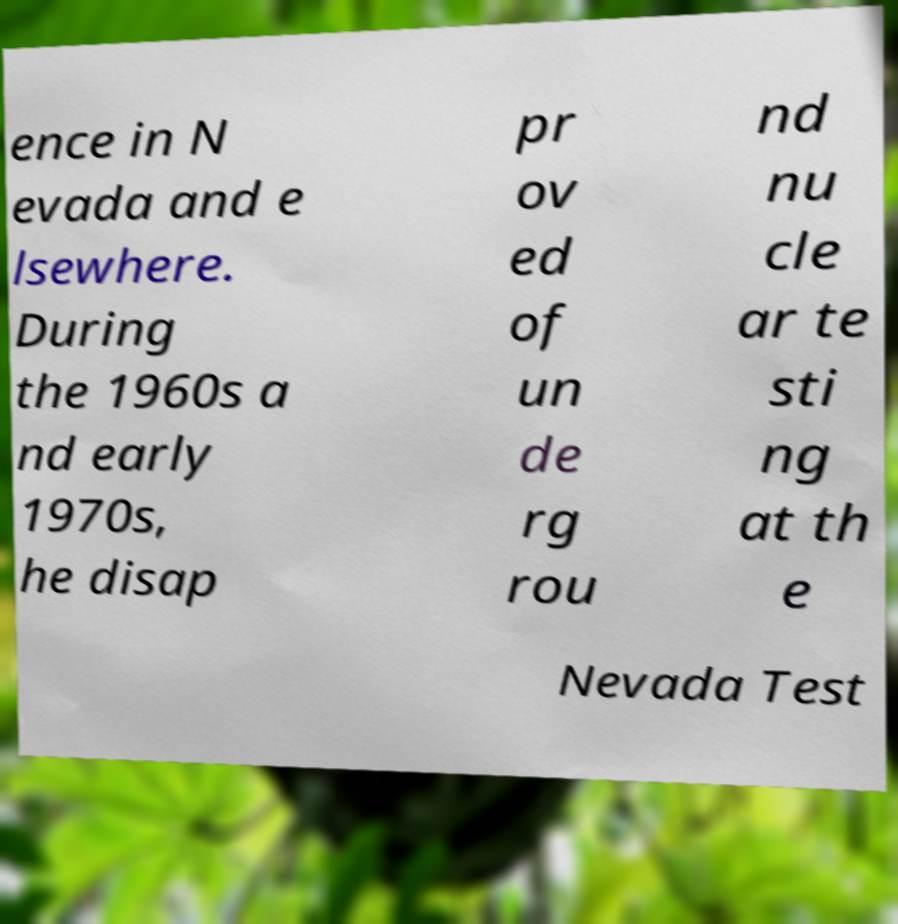Could you extract and type out the text from this image? ence in N evada and e lsewhere. During the 1960s a nd early 1970s, he disap pr ov ed of un de rg rou nd nu cle ar te sti ng at th e Nevada Test 